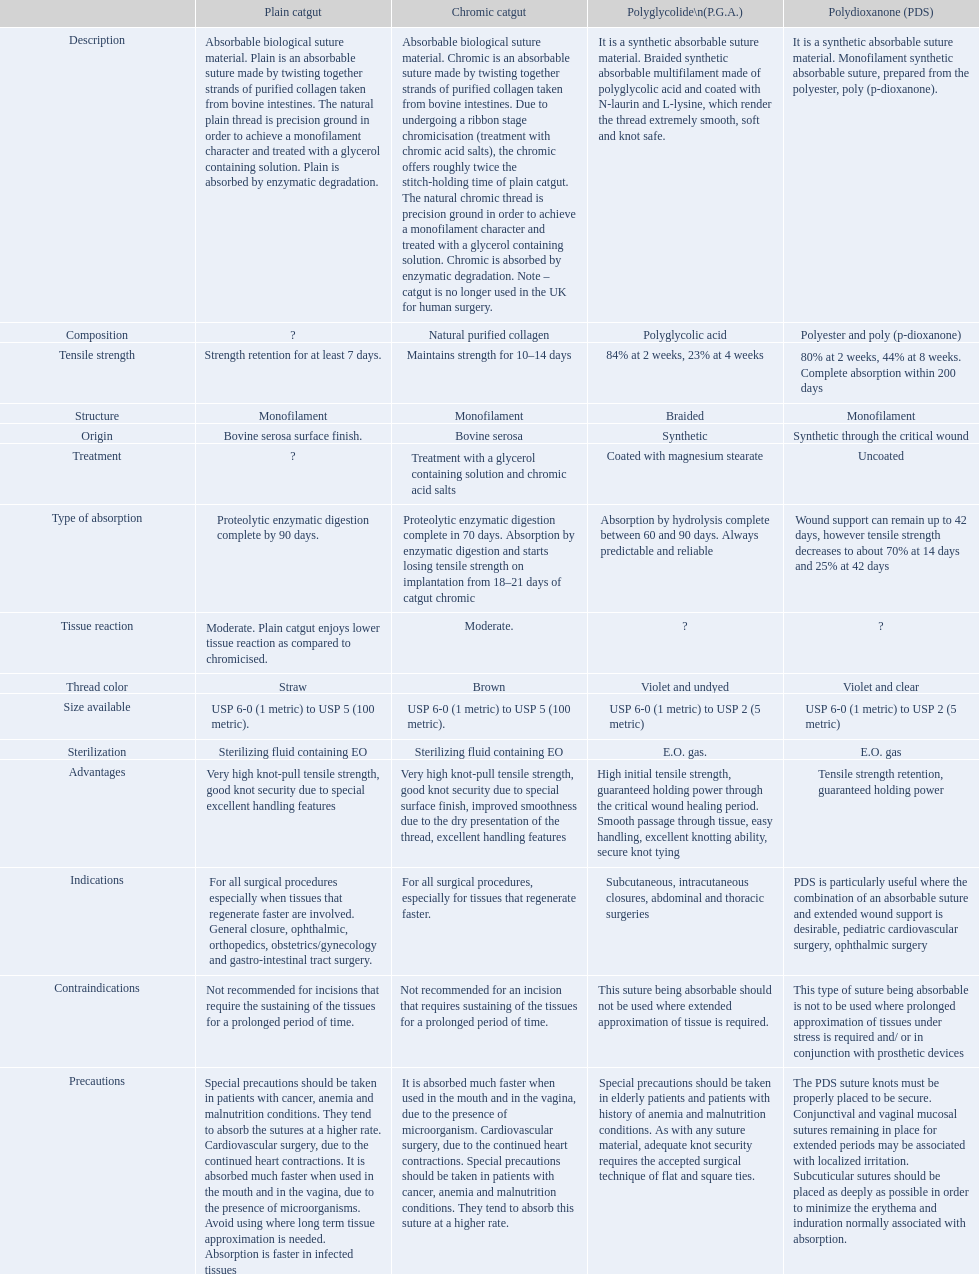What are the distinct tensile strengths of the suture materials in the comparison diagram? Strength retention for at least 7 days., Maintains strength for 10–14 days, 84% at 2 weeks, 23% at 4 weeks, 80% at 2 weeks, 44% at 8 weeks. Complete absorption within 200 days. From these, which is attributed to plain catgut? Strength retention for at least 7 days. 